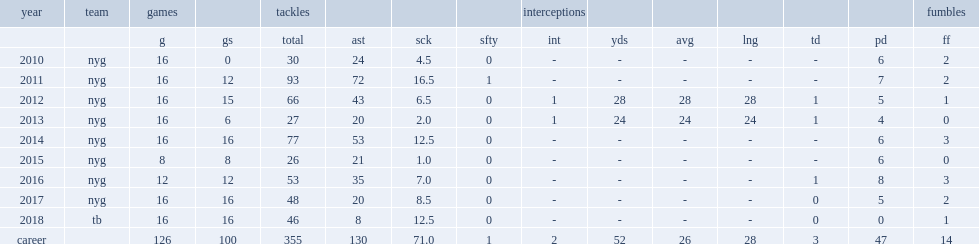How many fumbles did pierre-paul make during the 2011 season? 2.0. 